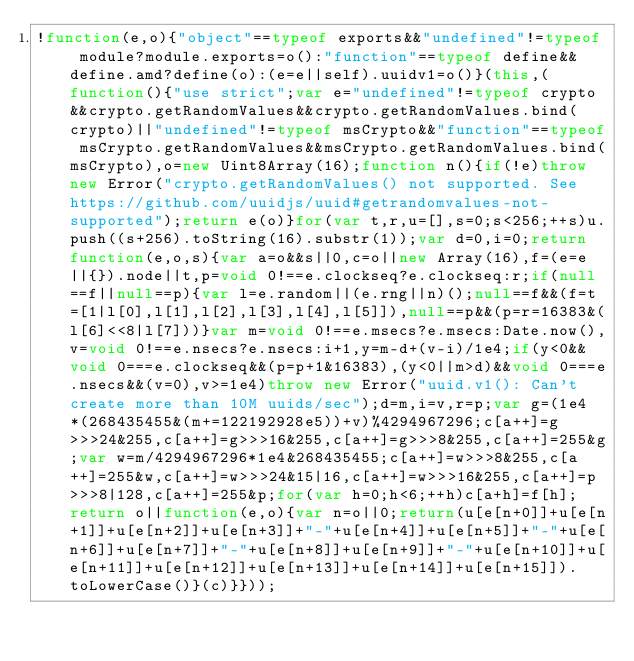Convert code to text. <code><loc_0><loc_0><loc_500><loc_500><_JavaScript_>!function(e,o){"object"==typeof exports&&"undefined"!=typeof module?module.exports=o():"function"==typeof define&&define.amd?define(o):(e=e||self).uuidv1=o()}(this,(function(){"use strict";var e="undefined"!=typeof crypto&&crypto.getRandomValues&&crypto.getRandomValues.bind(crypto)||"undefined"!=typeof msCrypto&&"function"==typeof msCrypto.getRandomValues&&msCrypto.getRandomValues.bind(msCrypto),o=new Uint8Array(16);function n(){if(!e)throw new Error("crypto.getRandomValues() not supported. See https://github.com/uuidjs/uuid#getrandomvalues-not-supported");return e(o)}for(var t,r,u=[],s=0;s<256;++s)u.push((s+256).toString(16).substr(1));var d=0,i=0;return function(e,o,s){var a=o&&s||0,c=o||new Array(16),f=(e=e||{}).node||t,p=void 0!==e.clockseq?e.clockseq:r;if(null==f||null==p){var l=e.random||(e.rng||n)();null==f&&(f=t=[1|l[0],l[1],l[2],l[3],l[4],l[5]]),null==p&&(p=r=16383&(l[6]<<8|l[7]))}var m=void 0!==e.msecs?e.msecs:Date.now(),v=void 0!==e.nsecs?e.nsecs:i+1,y=m-d+(v-i)/1e4;if(y<0&&void 0===e.clockseq&&(p=p+1&16383),(y<0||m>d)&&void 0===e.nsecs&&(v=0),v>=1e4)throw new Error("uuid.v1(): Can't create more than 10M uuids/sec");d=m,i=v,r=p;var g=(1e4*(268435455&(m+=122192928e5))+v)%4294967296;c[a++]=g>>>24&255,c[a++]=g>>>16&255,c[a++]=g>>>8&255,c[a++]=255&g;var w=m/4294967296*1e4&268435455;c[a++]=w>>>8&255,c[a++]=255&w,c[a++]=w>>>24&15|16,c[a++]=w>>>16&255,c[a++]=p>>>8|128,c[a++]=255&p;for(var h=0;h<6;++h)c[a+h]=f[h];return o||function(e,o){var n=o||0;return(u[e[n+0]]+u[e[n+1]]+u[e[n+2]]+u[e[n+3]]+"-"+u[e[n+4]]+u[e[n+5]]+"-"+u[e[n+6]]+u[e[n+7]]+"-"+u[e[n+8]]+u[e[n+9]]+"-"+u[e[n+10]]+u[e[n+11]]+u[e[n+12]]+u[e[n+13]]+u[e[n+14]]+u[e[n+15]]).toLowerCase()}(c)}}));</code> 